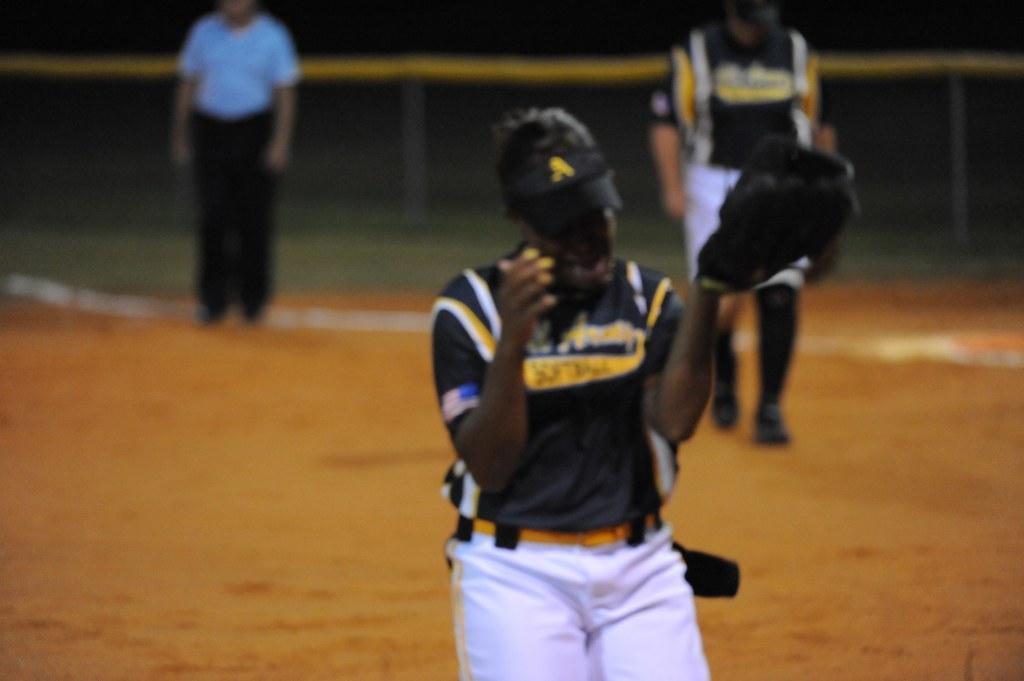Can you describe this image briefly? In the foreground of this image, there is a man standing in black and white dress and wearing glove to his hand. In the background, there are two persons standing on the ground and a fencing. 